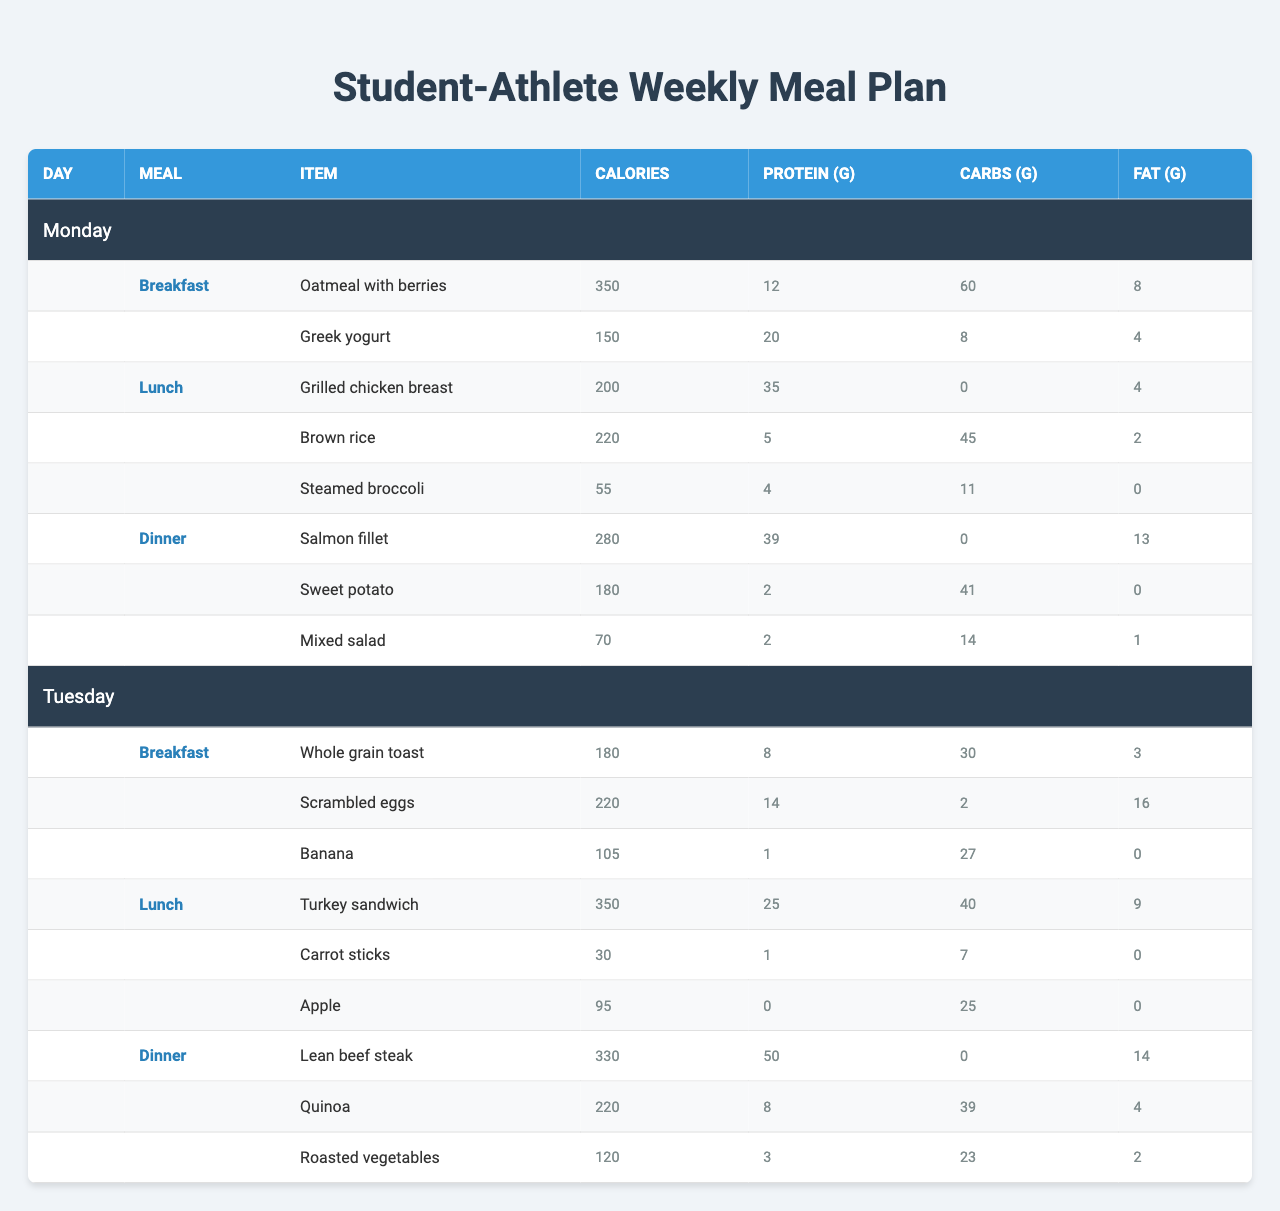What are the total calories for Monday's lunch? The items for Monday's lunch are grilled chicken breast (200 calories), brown rice (220 calories), and steamed broccoli (55 calories). Summing these gives 200 + 220 + 55 = 475 calories.
Answer: 475 calories What is the protein content in Tuesday's breakfast? The items in Tuesday's breakfast are whole grain toast (8g), scrambled eggs (14g), and a banana (1g). Adding these together gives 8 + 14 + 1 = 23 grams of protein.
Answer: 23 grams Does the meal plan include any meals that contain zero carbohydrates? The grilled chicken breast and salmon fillet both contain zero carbohydrates. Therefore, the statement is true.
Answer: Yes What is the average number of calories consumed per meal on Monday? On Monday, the meals and their calories are: Breakfast (350), Lunch (475), and Dinner (530). To find the average, sum the calories: 350 + 475 + 530 = 1355, and divide by 3 (the number of meals), which equals approximately 451.67 calories.
Answer: 451.67 calories Which meal on Tuesday contains the highest amount of fat? Reviewing the fat content: Tuesday's breakfast has 19g (toast 3g + scrambled eggs 16g + banana 0g), lunch has 9g (turkey sandwich 9g + carrot sticks 0g + apple 0g), and dinner has 14g (lean beef steak 14g + quinoa 4g + roasted vegetables 2g). The highest fat content is in the dinner at 14g.
Answer: Dinner What is the total amount of protein across all meals for Monday? For Monday's meals: Breakfast has 12g (oatmeal) + 20g (yogurt) = 32g, Lunch has 35g (chicken) + 5g (rice) + 4g (broccoli) = 44g, Dinner has 39g (salmon) + 2g (sweet potato) + 2g (salad) = 43g. Adding these together: 32 + 44 + 43 = 119g.
Answer: 119g 